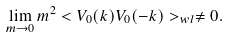<formula> <loc_0><loc_0><loc_500><loc_500>\lim _ { m \rightarrow 0 } m ^ { 2 } < V _ { 0 } ( k ) V _ { 0 } ( - k ) > _ { w l } \neq 0 .</formula> 